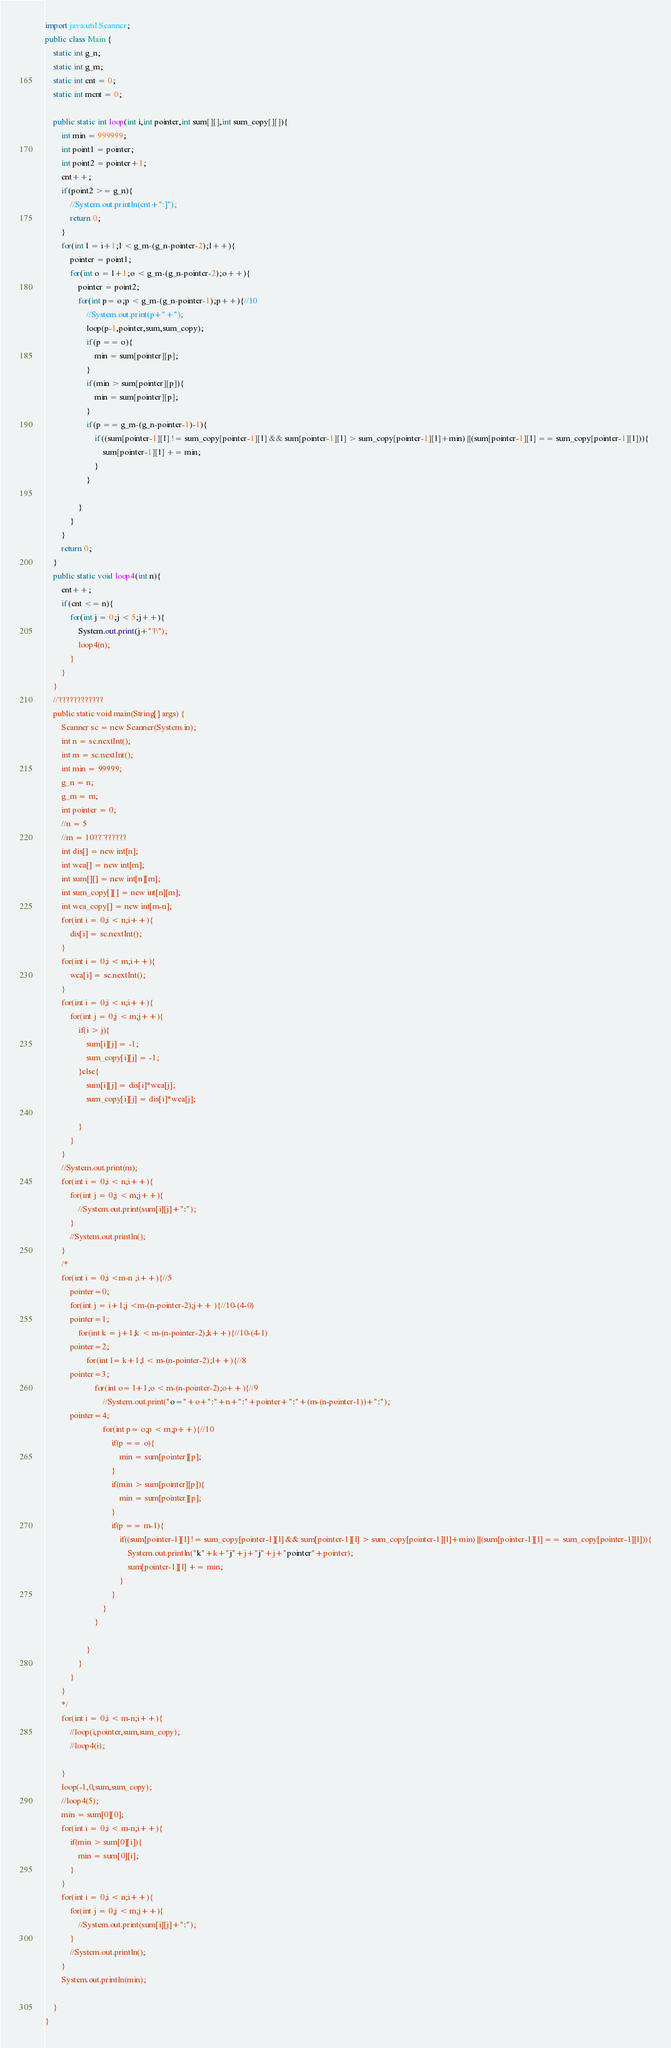Convert code to text. <code><loc_0><loc_0><loc_500><loc_500><_Java_>import java.util.Scanner;
public class Main {
	static int g_n;
	static int g_m;
	static int cnt = 0;
	static int mcnt = 0;

	public static int loop(int i,int pointer,int sum[][],int sum_copy[][]){
		int min = 999999;
		int point1 = pointer;
		int point2 = pointer+1;
		cnt++;
		if(point2 >= g_n){
			//System.out.println(cnt+":]");
			return 0;
		}
		for(int l = i+1;l < g_m-(g_n-pointer-2);l++){
			pointer = point1;
			for(int o = l+1;o < g_m-(g_n-pointer-2);o++){
				pointer = point2;
				for(int p= o;p < g_m-(g_n-pointer-1);p++){//10
					//System.out.print(p+"+");
					loop(p-1,pointer,sum,sum_copy);
					if(p == o){
						min = sum[pointer][p];
					}
					if(min > sum[pointer][p]){
						min = sum[pointer][p];
					}
					if(p == g_m-(g_n-pointer-1)-1){							
						if((sum[pointer-1][l] != sum_copy[pointer-1][l] && sum[pointer-1][l] > sum_copy[pointer-1][l]+min) ||(sum[pointer-1][l] == sum_copy[pointer-1][l])){
							sum[pointer-1][l] += min; 
						}	
					}
					
				}
			}
		}
		return 0;
	}
	public static void loop4(int n){
		cnt++;
		if(cnt <= n){
			for(int j = 0;j < 5;j++){
				System.out.print(j+"?\");
				loop4(n);
			}
		}
	}
	//????????????
	public static void main(String[] args) {
		Scanner sc = new Scanner(System.in);
		int n = sc.nextInt();
		int m = sc.nextInt();
		int min = 99999;
		g_n = n;
		g_m = m;
		int pointer = 0;
		//n = 5
		//m = 10??¨??????
		int dis[] = new int[n];
		int wea[] = new int[m];
		int sum[][] = new int[n][m];
		int sum_copy[][] = new int[n][m];
		int wea_copy[] = new int[m-n];
		for(int i = 0;i < n;i++){
			dis[i] = sc.nextInt();
		}
		for(int i = 0;i < m;i++){
			wea[i] = sc.nextInt();
		}
		for(int i = 0;i < n;i++){
			for(int j = 0;j < m;j++){
				if(i > j){
					sum[i][j] = -1;
					sum_copy[i][j] = -1;
				}else{
					sum[i][j] = dis[i]*wea[j];
					sum_copy[i][j] = dis[i]*wea[j];

				}
			}
		}
		//System.out.print(m);
		for(int i = 0;i < n;i++){
			for(int j = 0;j < m;j++){
				//System.out.print(sum[i][j]+":");	
			}
			//System.out.println();
		}
		/*
		for(int i = 0;i <m-n ;i++){//5
			pointer=0;
			for(int j = i+1;j <m-(n-pointer-2);j++ ){//10-(4-0)
			pointer=1;
				for(int k = j+1;k < m-(n-pointer-2);k++){//10-(4-1)
			pointer=2;
					for(int l= k+1;l < m-(n-pointer-2);l++){//8
			pointer=3;
						for(int o= l+1;o < m-(n-pointer-2);o++){//9
							//System.out.print("o="+o+":"+n+":"+pointer+":"+(m-(n-pointer-1))+":");
			pointer=4;
							for(int p= o;p < m;p++){//10
								if(p == o){
									min = sum[pointer][p];
								}
								if(min > sum[pointer][p]){
									min = sum[pointer][p];
								}
								if(p == m-1){							
									if((sum[pointer-1][l] != sum_copy[pointer-1][l] && sum[pointer-1][l] > sum_copy[pointer-1][l]+min) ||(sum[pointer-1][l] == sum_copy[pointer-1][l])){
										System.out.println("k"+k+"j"+j+"j"+j+"pointer"+pointer);
										sum[pointer-1][l] += min; 
									}	
								}
							}
						}

					}	
				}
			}
		}
		*/
		for(int i = 0;i < m-n;i++){
			//loop(i,pointer,sum,sum_copy);
			//loop4(i);

		}
		loop(-1,0,sum,sum_copy);
		//loop4(5);
		min = sum[0][0];
		for(int i = 0;i < m-n;i++){
			if(min > sum[0][i]){
				min = sum[0][i];
			}
		}
		for(int i = 0;i < n;i++){
			for(int j = 0;j < m;j++){
				//System.out.print(sum[i][j]+":");	
			}
			//System.out.println();
		}	
		System.out.println(min);

	}
}</code> 